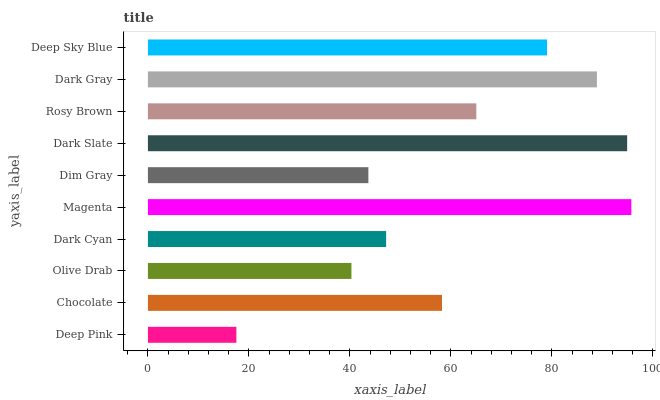Is Deep Pink the minimum?
Answer yes or no. Yes. Is Magenta the maximum?
Answer yes or no. Yes. Is Chocolate the minimum?
Answer yes or no. No. Is Chocolate the maximum?
Answer yes or no. No. Is Chocolate greater than Deep Pink?
Answer yes or no. Yes. Is Deep Pink less than Chocolate?
Answer yes or no. Yes. Is Deep Pink greater than Chocolate?
Answer yes or no. No. Is Chocolate less than Deep Pink?
Answer yes or no. No. Is Rosy Brown the high median?
Answer yes or no. Yes. Is Chocolate the low median?
Answer yes or no. Yes. Is Deep Pink the high median?
Answer yes or no. No. Is Deep Pink the low median?
Answer yes or no. No. 